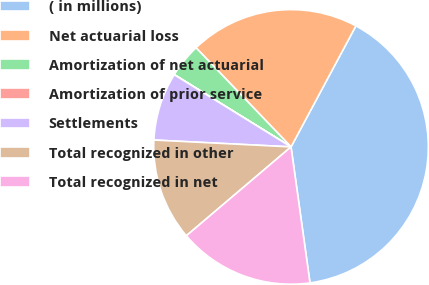Convert chart to OTSL. <chart><loc_0><loc_0><loc_500><loc_500><pie_chart><fcel>( in millions)<fcel>Net actuarial loss<fcel>Amortization of net actuarial<fcel>Amortization of prior service<fcel>Settlements<fcel>Total recognized in other<fcel>Total recognized in net<nl><fcel>39.96%<fcel>19.99%<fcel>4.01%<fcel>0.02%<fcel>8.01%<fcel>12.0%<fcel>16.0%<nl></chart> 